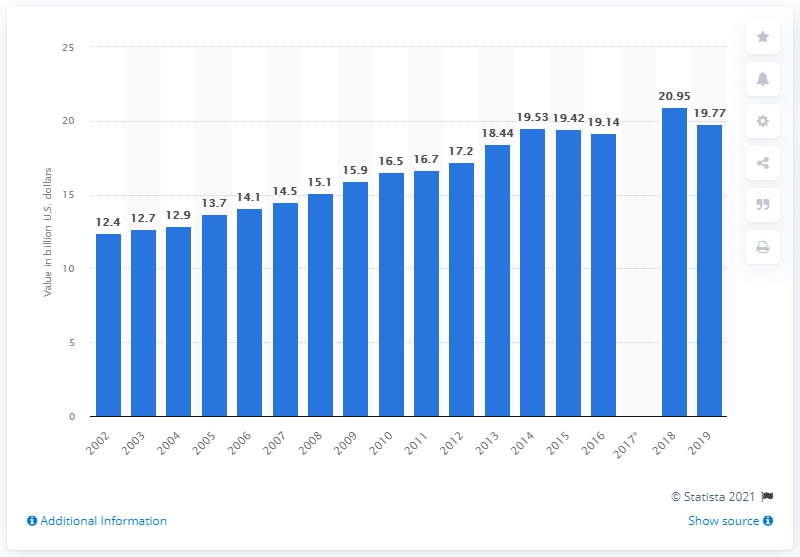Point out several critical features in this image. In 2019, the value of U.S. product shipments of frozen specialty foods was 19.77. 